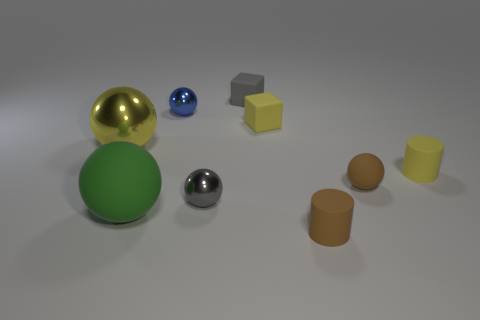Subtract all spheres. How many objects are left? 4 Add 3 green objects. How many green objects exist? 4 Subtract 0 red spheres. How many objects are left? 9 Subtract all tiny red shiny cylinders. Subtract all yellow shiny spheres. How many objects are left? 8 Add 6 small yellow things. How many small yellow things are left? 8 